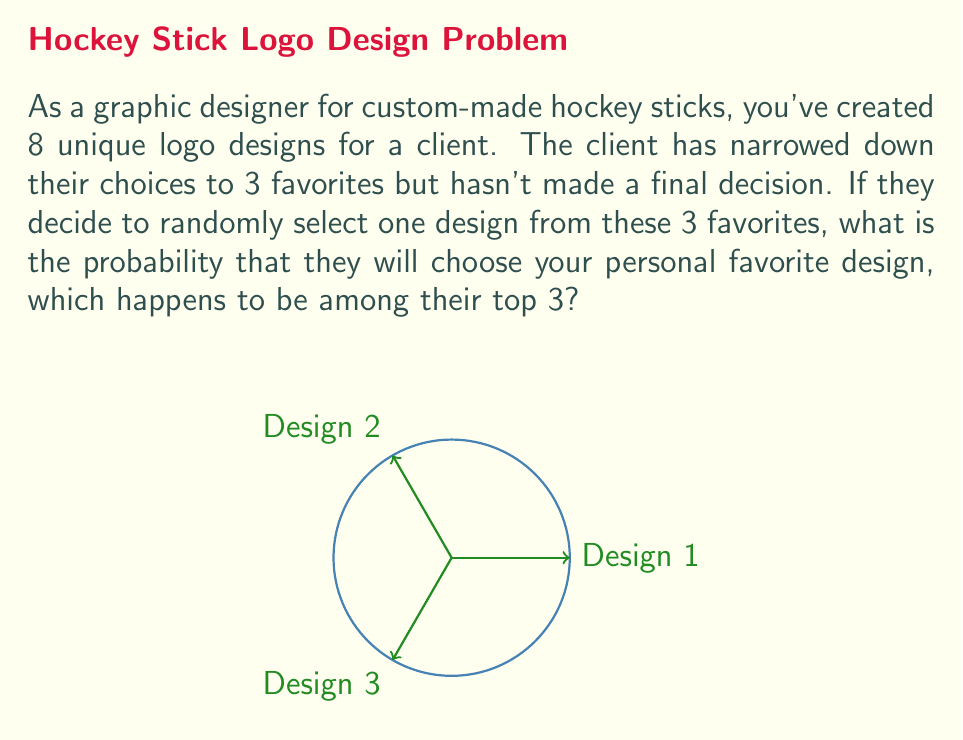What is the answer to this math problem? To solve this probability problem, we need to follow these steps:

1. Identify the sample space:
   The sample space consists of the 3 favorite designs the client is choosing from.

2. Identify the favorable outcome:
   The favorable outcome is your personal favorite design being chosen.

3. Calculate the probability:
   The probability of an event is given by the formula:

   $$P(\text{event}) = \frac{\text{number of favorable outcomes}}{\text{total number of possible outcomes}}$$

   In this case:
   - Number of favorable outcomes: 1 (your personal favorite design)
   - Total number of possible outcomes: 3 (the client's top 3 designs)

   Therefore, the probability is:

   $$P(\text{personal favorite chosen}) = \frac{1}{3}$$

4. Convert to a percentage (optional):
   To express this as a percentage, we multiply by 100:

   $$\frac{1}{3} \times 100 = 33.33\%$$

Thus, there is a $\frac{1}{3}$ or approximately 33.33% chance that the client will randomly select your personal favorite design from their top 3 choices.
Answer: $\frac{1}{3}$ 